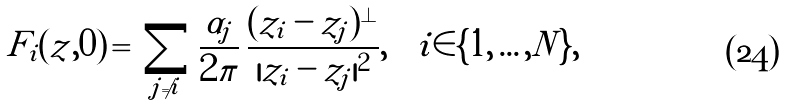<formula> <loc_0><loc_0><loc_500><loc_500>F _ { i } ( z , 0 ) \, = \, \sum _ { j \neq i } \frac { \alpha _ { j } } { 2 \pi } \, \frac { ( z _ { i } - z _ { j } ) ^ { \perp } } { | z _ { i } - z _ { j } | ^ { 2 } } , \quad i \in \{ 1 , \dots , N \} ,</formula> 